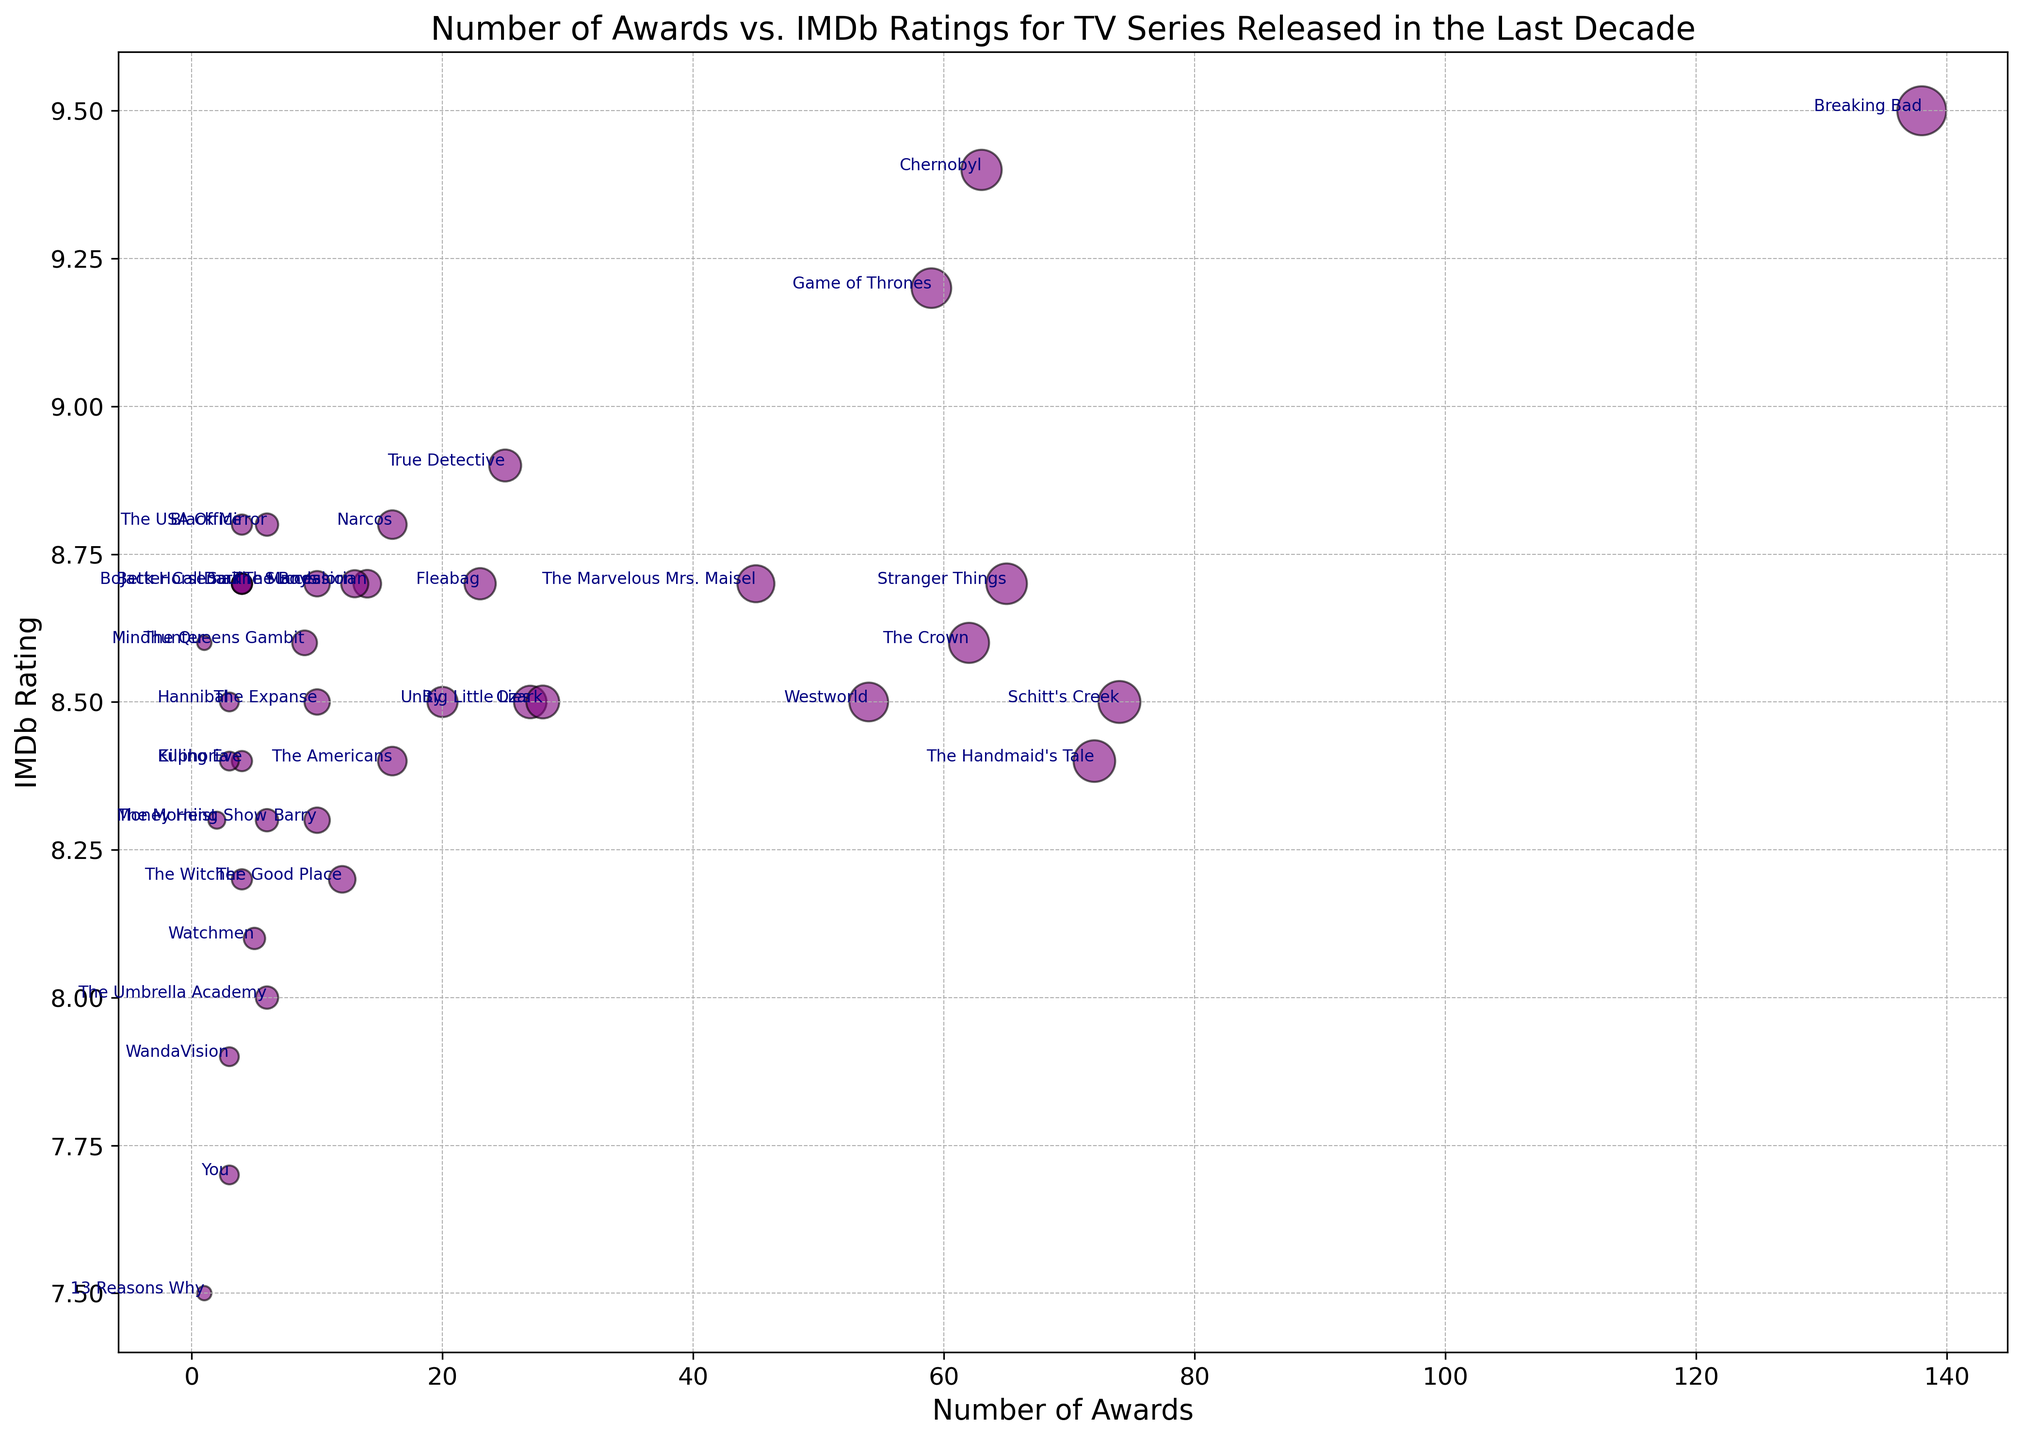Which TV series has the highest number of awards with an IMDb rating of 8.7? First, identify the TV series with an IMDb rating of 8.7. These include Fleabag, Stranger Things, The Mandalorian, The Marvelous Mrs. Maisel, BoJack Horseman, Better Call Saul, Dark, and Succession. Among these, Stranger Things has the highest number of awards with 65.
Answer: Stranger Things What is the difference in IMDb ratings between the highest-rated series and the lowest-rated series? The highest-rated series is Breaking Bad with a rating of 9.5, while the lowest-rated series is 13 Reasons Why with a rating of 7.5. The difference is 9.5 - 7.5 = 2.
Answer: 2 How many TV series have an IMDb rating of 8.5? Identify all series with an IMDb rating of 8.5. These series are Schitt's Creek, Big Little Lies, Westworld, Ozark, The Expanse, Hannibal, and Unity. There are 7 series in total.
Answer: 7 Which TV series with more than 50 awards has the lowest IMDb rating? Filter out TV series with more than 50 awards. These include Game of Thrones (59, 9.2), Breaking Bad (138, 9.5), Stranger Things (65, 8.7), The Crown (62, 8.6), The Handmaid's Tale (72, 8.4), and Chernobyl (63, 9.4). The lowest IMDb rating among these is The Handmaid's Tale with 8.4.
Answer: The Handmaid's Tale Which TV series is represented by the largest marker on the plot? The size of the markers represents the number of awards. The series with the largest number of awards is Breaking Bad with 138 awards.
Answer: Breaking Bad What is the average IMDb rating of TV series with fewer than 10 awards? The TV series with fewer than 10 awards are Mindhunter (8.6), The USA Office (8.8), BoJack Horseman (8.7), Better Call Saul (8.7), Killing Eve (8.4), WandaVision (7.9), 13 Reasons Why (7.5), You (7.7), Money Heist (8.3), and Hannibal (8.5). Sum their ratings: 8.6 + 8.8 + 8.7 + 8.7 + 8.4 + 7.9 + 7.5 + 7.7 + 8.3 + 8.5 = 83.1. The average is 83.1 / 10 = 8.31.
Answer: 8.31 